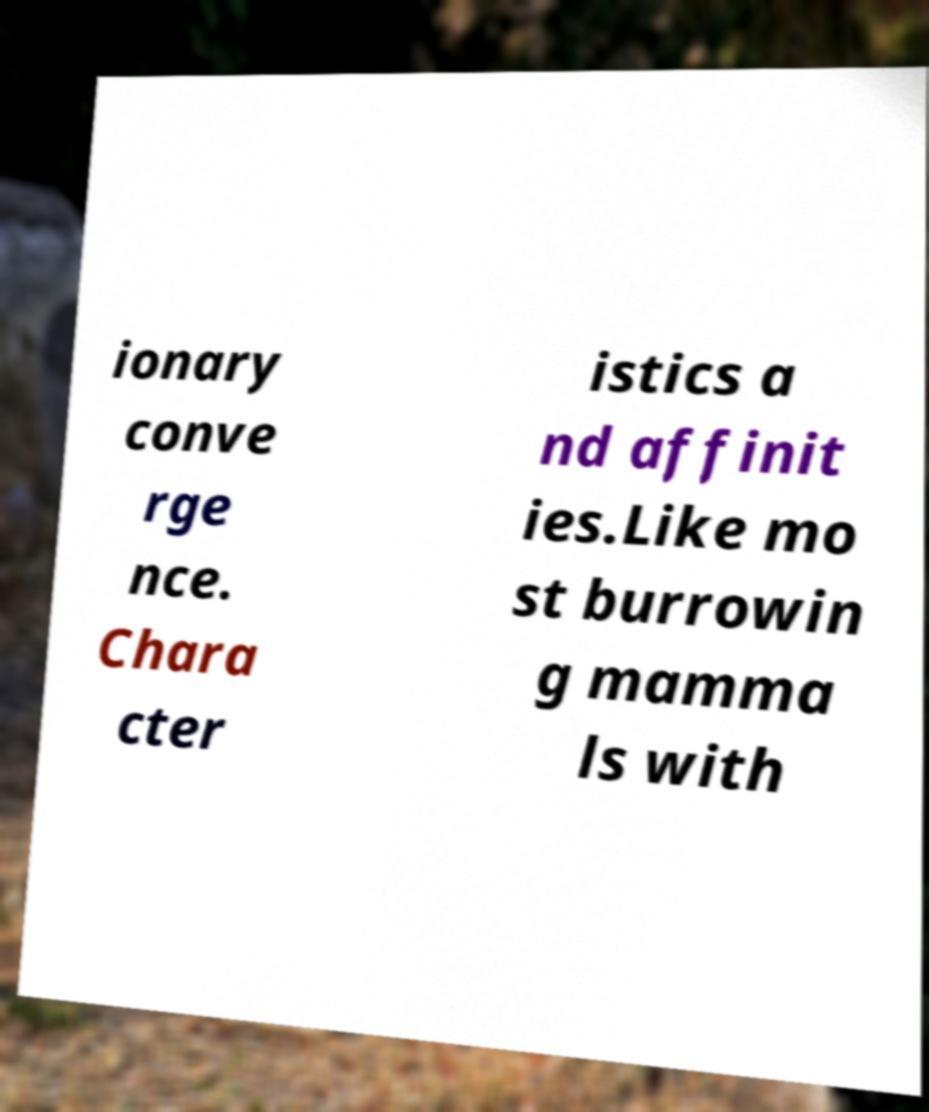There's text embedded in this image that I need extracted. Can you transcribe it verbatim? ionary conve rge nce. Chara cter istics a nd affinit ies.Like mo st burrowin g mamma ls with 